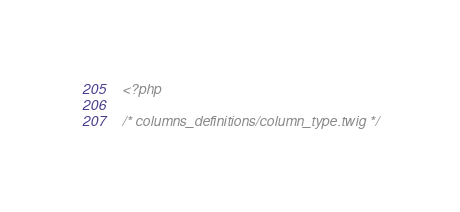<code> <loc_0><loc_0><loc_500><loc_500><_PHP_><?php

/* columns_definitions/column_type.twig */</code> 